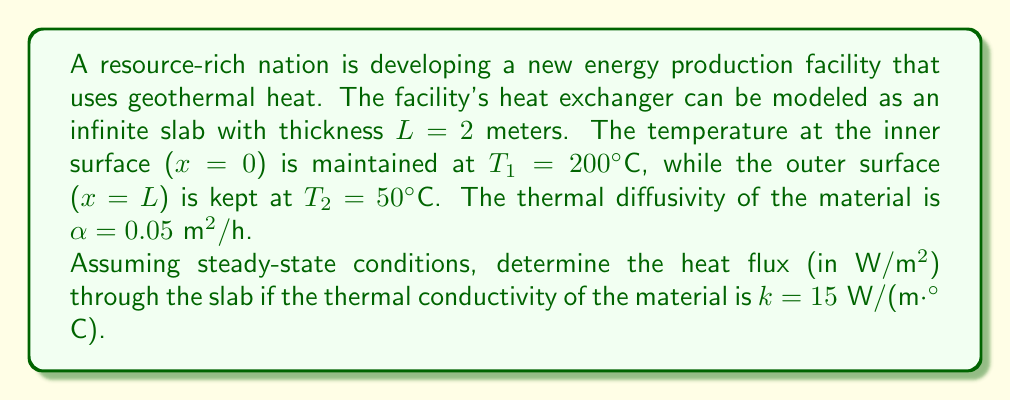Can you answer this question? To solve this problem, we'll use the steady-state heat equation and Fourier's law of heat conduction. Here's the step-by-step solution:

1) In steady-state conditions, the temperature distribution in the slab is linear. We can express it as:

   $$T(x) = T_1 + \frac{T_2 - T_1}{L}x$$

2) The temperature gradient is constant and can be calculated as:

   $$\frac{dT}{dx} = \frac{T_2 - T_1}{L}$$

3) Substituting the given values:

   $$\frac{dT}{dx} = \frac{50°C - 200°C}{2\text{ m}} = -75 \text{ °C/m}$$

4) Fourier's law of heat conduction states that the heat flux $q$ is proportional to the negative temperature gradient:

   $$q = -k\frac{dT}{dx}$$

5) Substituting the thermal conductivity and the temperature gradient:

   $$q = -15 \text{ W/(m·°C)} \cdot (-75 \text{ °C/m})$$

6) Simplifying:

   $$q = 1125 \text{ W/m}^2$$

Thus, the heat flux through the slab is 1125 W/m².
Answer: 1125 W/m² 